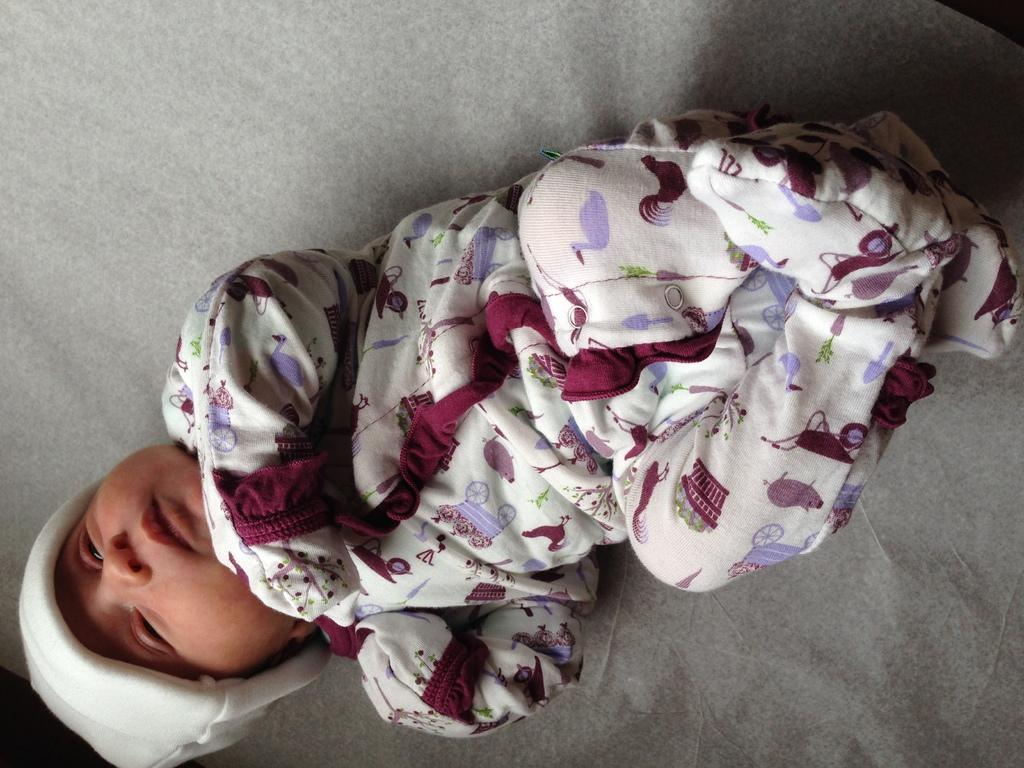What is the main subject of the image? The main subject of the image is a baby. Can you describe the surface the baby is lying on? The baby is lying on a grey surface. What type of bee can be seen buzzing around the baby in the image? There is no bee present in the image; the baby is lying on a grey surface. How much cream is visible on the baby's face in the image? There is no cream visible on the baby's face in the image. 